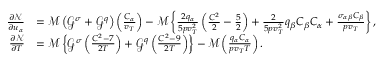Convert formula to latex. <formula><loc_0><loc_0><loc_500><loc_500>\begin{array} { r l } { \frac { \partial \mathcal { N } } { \partial u _ { \alpha } } } & { = \mathcal { M } \left ( \mathcal { G } ^ { \sigma } + \mathcal { G } ^ { q } \right ) \left ( \frac { C _ { \alpha } } { v _ { T } } \right ) - \mathcal { M } \left \{ \frac { 2 q _ { \alpha } } { 5 p v _ { T } ^ { 2 } } \left ( \frac { C ^ { 2 } } { 2 } - \frac { 5 } { 2 } \right ) + \frac { 2 } { 5 p v _ { T } ^ { 2 } } q _ { \beta } C _ { \beta } C _ { \alpha } + \frac { \sigma _ { \alpha \beta } C _ { \beta } } { p v _ { T } } \right \} , } \\ { \frac { \partial \mathcal { N } } { \partial T } } & { = \mathcal { M } \left \{ \mathcal { G } ^ { \sigma } \left ( \frac { C ^ { 2 } - 7 } { 2 T } \right ) + \mathcal { G } ^ { q } \left ( \frac { C ^ { 2 } - 9 } { 2 T } \right ) \right \} - \mathcal { M } \left ( \frac { q _ { \alpha } C _ { \alpha } } { p v _ { T } T } \right ) . } \end{array}</formula> 